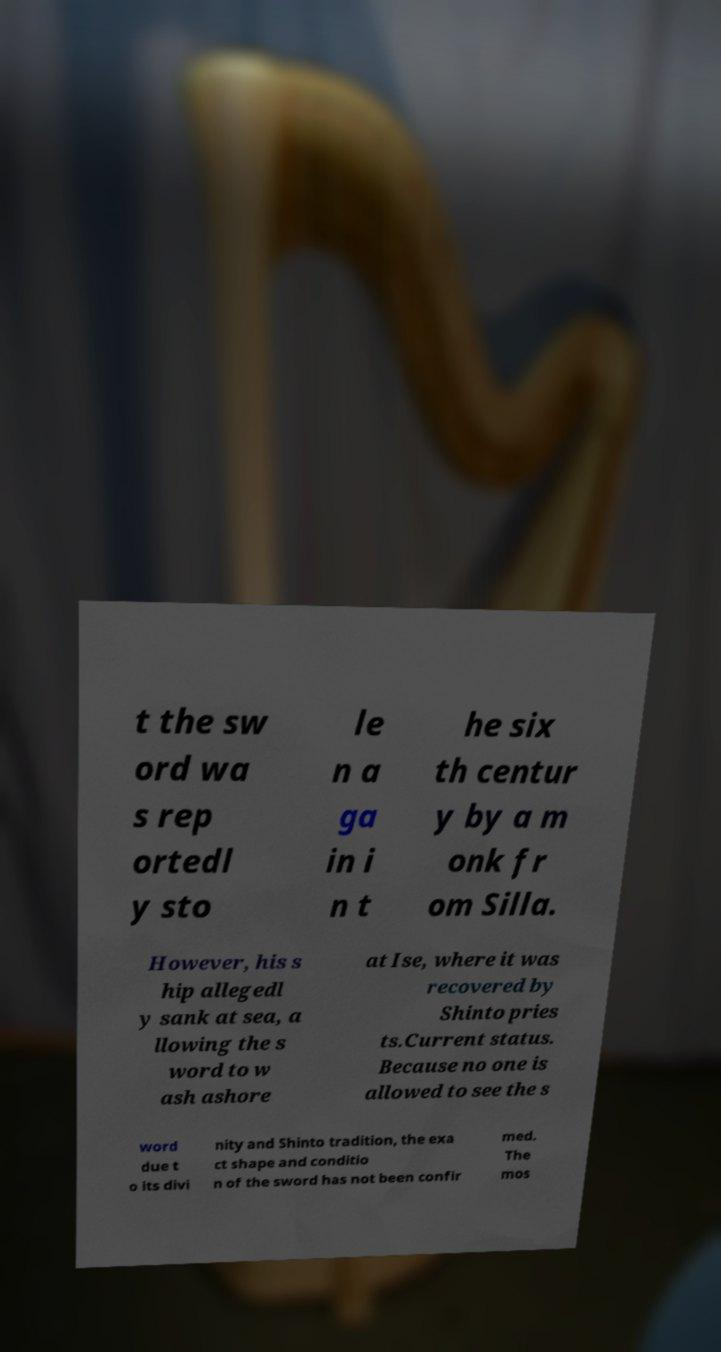I need the written content from this picture converted into text. Can you do that? t the sw ord wa s rep ortedl y sto le n a ga in i n t he six th centur y by a m onk fr om Silla. However, his s hip allegedl y sank at sea, a llowing the s word to w ash ashore at Ise, where it was recovered by Shinto pries ts.Current status. Because no one is allowed to see the s word due t o its divi nity and Shinto tradition, the exa ct shape and conditio n of the sword has not been confir med. The mos 